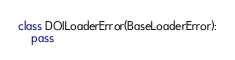<code> <loc_0><loc_0><loc_500><loc_500><_Python_>
class DOILoaderError(BaseLoaderError):
    pass
</code> 